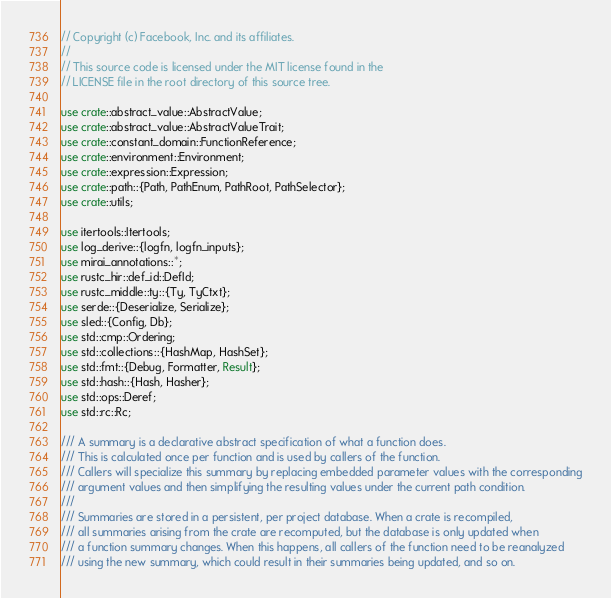Convert code to text. <code><loc_0><loc_0><loc_500><loc_500><_Rust_>// Copyright (c) Facebook, Inc. and its affiliates.
//
// This source code is licensed under the MIT license found in the
// LICENSE file in the root directory of this source tree.

use crate::abstract_value::AbstractValue;
use crate::abstract_value::AbstractValueTrait;
use crate::constant_domain::FunctionReference;
use crate::environment::Environment;
use crate::expression::Expression;
use crate::path::{Path, PathEnum, PathRoot, PathSelector};
use crate::utils;

use itertools::Itertools;
use log_derive::{logfn, logfn_inputs};
use mirai_annotations::*;
use rustc_hir::def_id::DefId;
use rustc_middle::ty::{Ty, TyCtxt};
use serde::{Deserialize, Serialize};
use sled::{Config, Db};
use std::cmp::Ordering;
use std::collections::{HashMap, HashSet};
use std::fmt::{Debug, Formatter, Result};
use std::hash::{Hash, Hasher};
use std::ops::Deref;
use std::rc::Rc;

/// A summary is a declarative abstract specification of what a function does.
/// This is calculated once per function and is used by callers of the function.
/// Callers will specialize this summary by replacing embedded parameter values with the corresponding
/// argument values and then simplifying the resulting values under the current path condition.
///
/// Summaries are stored in a persistent, per project database. When a crate is recompiled,
/// all summaries arising from the crate are recomputed, but the database is only updated when
/// a function summary changes. When this happens, all callers of the function need to be reanalyzed
/// using the new summary, which could result in their summaries being updated, and so on.</code> 